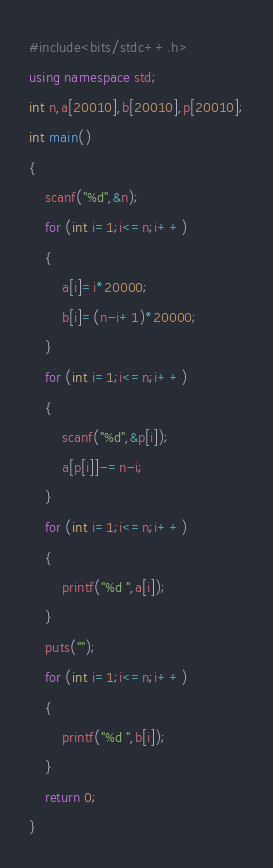<code> <loc_0><loc_0><loc_500><loc_500><_C++_>#include<bits/stdc++.h>
using namespace std;
int n,a[20010],b[20010],p[20010];
int main()
{
	scanf("%d",&n);
	for (int i=1;i<=n;i++)
	{
		a[i]=i*20000;
		b[i]=(n-i+1)*20000;
	}
	for (int i=1;i<=n;i++)
	{
		scanf("%d",&p[i]);
		a[p[i]]-=n-i;
	}
	for (int i=1;i<=n;i++)
	{
		printf("%d ",a[i]);
	}
	puts("");
	for (int i=1;i<=n;i++)
	{
		printf("%d ",b[i]);
	}
	return 0;
}
</code> 